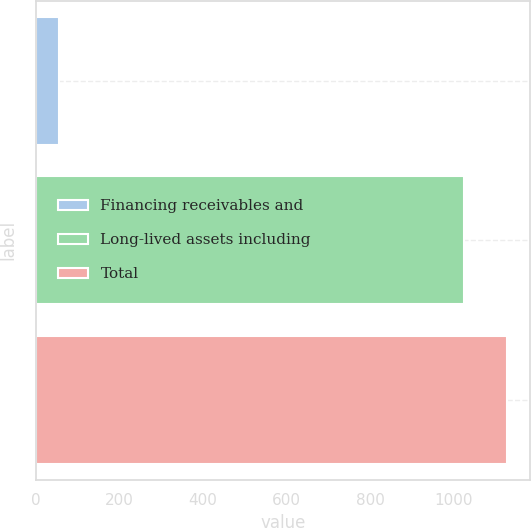Convert chart. <chart><loc_0><loc_0><loc_500><loc_500><bar_chart><fcel>Financing receivables and<fcel>Long-lived assets including<fcel>Total<nl><fcel>54<fcel>1025<fcel>1127.5<nl></chart> 